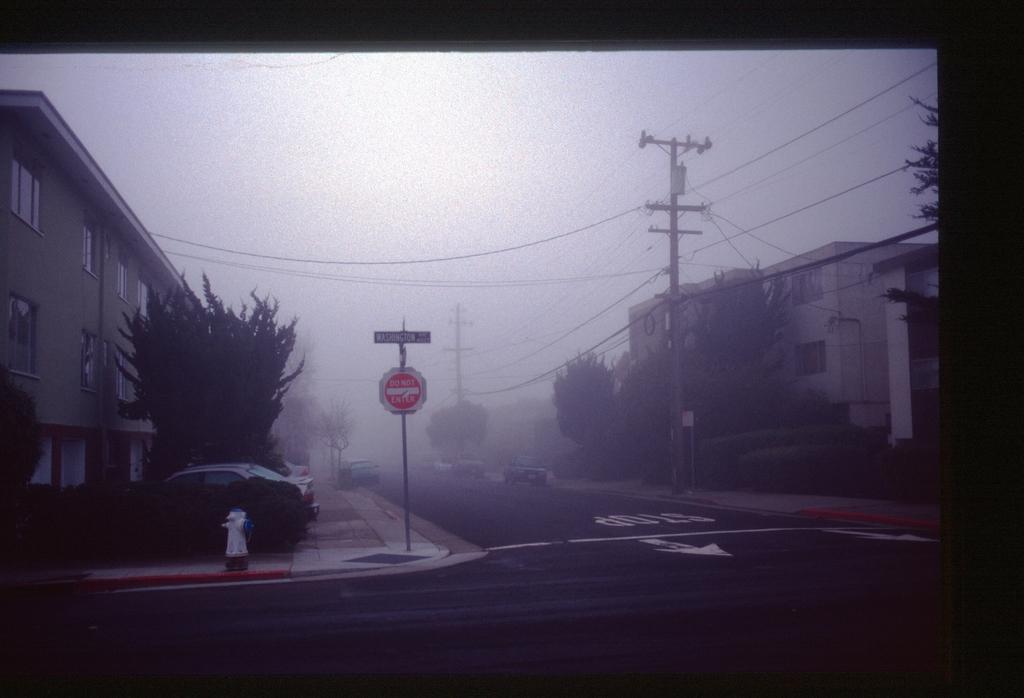How would you summarize this image in a sentence or two? In this image we can see the road, fire hydrant, caution board, vehicles moving on the road and vehicles parked here, we can see current poles, wires, trees, buildings, fog and the sky in the background. This part of the image is dark. 